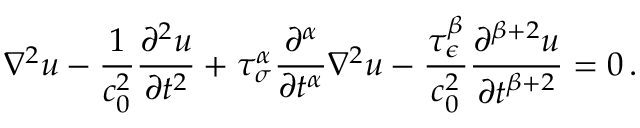<formula> <loc_0><loc_0><loc_500><loc_500>\nabla ^ { 2 } u - { \frac { 1 } { c _ { 0 } ^ { 2 } } } { \frac { \partial ^ { 2 } u } { \partial t ^ { 2 } } } + \tau _ { \sigma } ^ { \alpha } { \frac { \partial ^ { \alpha } } { \partial t ^ { \alpha } } } \nabla ^ { 2 } u - { \frac { \tau _ { \epsilon } ^ { \beta } } { c _ { 0 } ^ { 2 } } } { \frac { \partial ^ { \beta + 2 } u } { \partial t ^ { \beta + 2 } } } = 0 \, .</formula> 